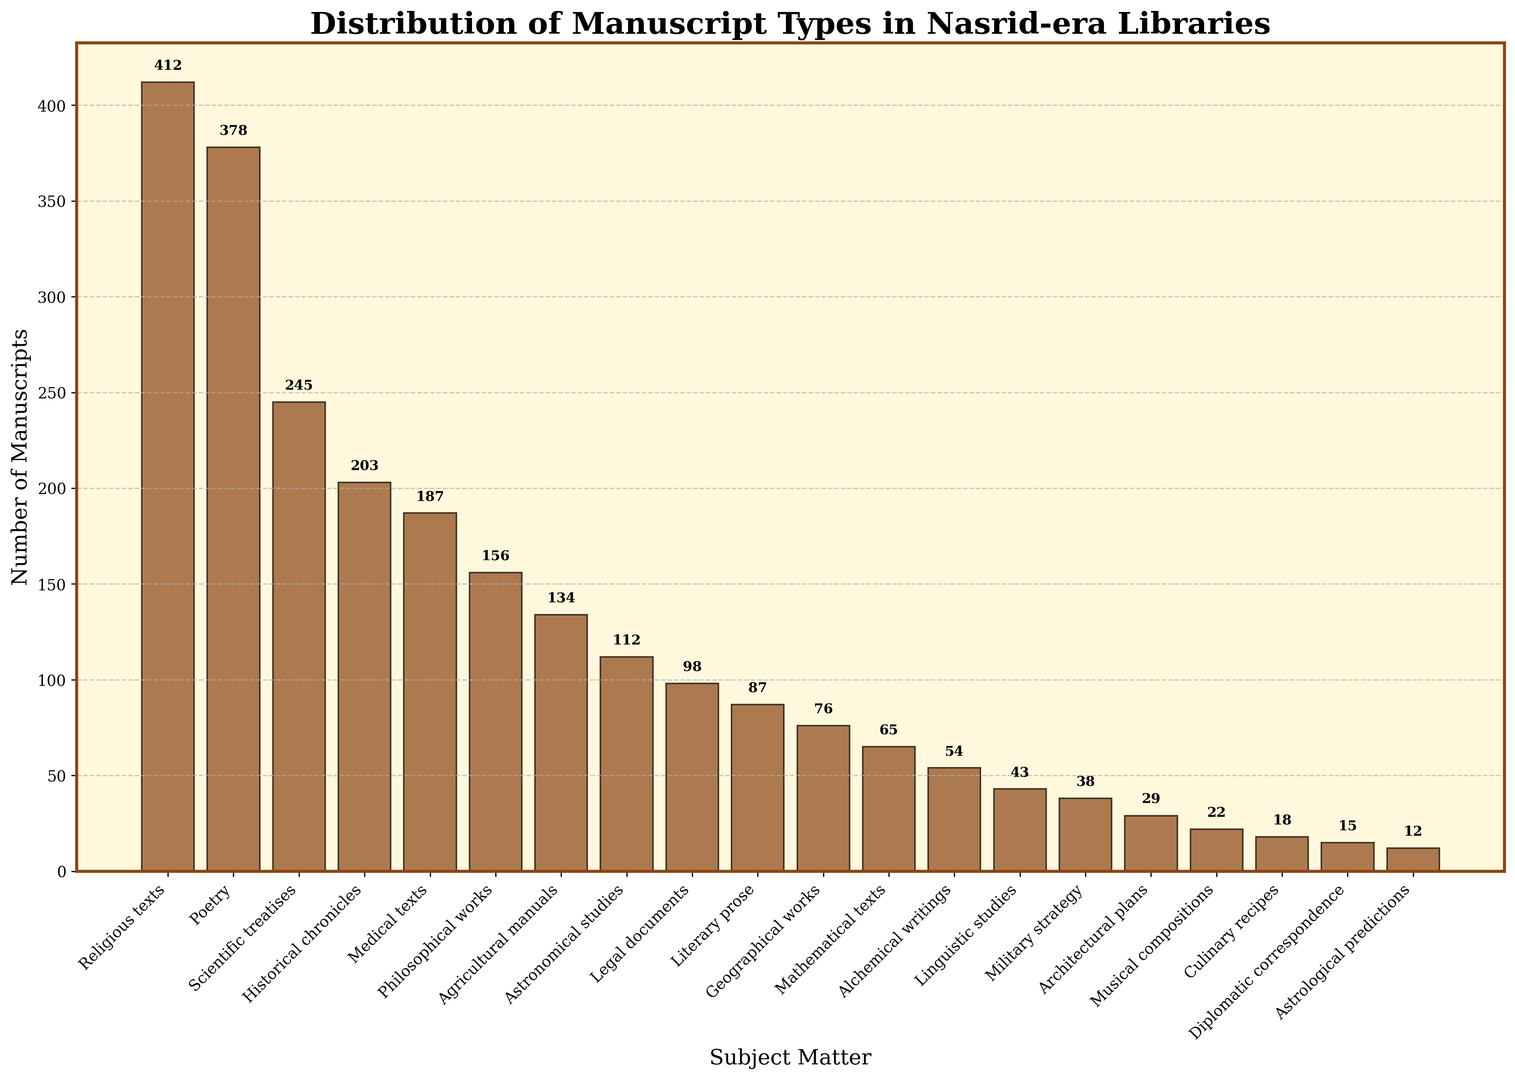Which subject matter has the highest number of manuscripts? By looking at the height of the bars, the highest bar corresponds to "Religious texts" which clearly exceeds the heights of the other bars.
Answer: Religious texts Which subject matter has the lowest number of manuscripts? Observing the bar heights, the shortest bar corresponds to "Astrological predictions," showing that it has the fewest manuscripts.
Answer: Astrological predictions How many more Religious texts are there than Astronomical studies? The bar for Religious texts is at 412 and the bar for Astronomical studies is at 112. Subtraction will give us the difference: 412 - 112 = 300.
Answer: 300 Which has more manuscripts: Poetry or Medical texts? Comparing the heights of the two bars, the bar for Poetry (378) is taller than the bar for Medical texts (187).
Answer: Poetry What is the total number of manuscripts for Agricultural manuals, Mathematical texts, and Culinary recipes combined? Add the values for these three categories: 134 (Agricultural manuals) + 65 (Mathematical texts) + 18 (Culinary recipes) = 217.
Answer: 217 Are there more manuscripts categorized under Historical chronicles or Scientific treatises? By comparing the bar heights, Scientific treatises (245) is taller than Historical chronicles (203).
Answer: Scientific treatises How many manuscripts are there in total for subjects that start with the letter "A"? Subjects that start with 'A' are Agricultural manuals (134), Astronomical studies (112), and Architectural plans (29). Adding these gives: 134 + 112 + 29 = 275.
Answer: 275 Which subject has more manuscripts: Philosophical works or Musical compositions? Comparing the bars, Philosophical works (156) is taller than Musical compositions (22).
Answer: Philosophical works What is the difference in the number of manuscripts between Legal documents and Geographical works? Looking at the bars for these subjects: Legal documents have 98 manuscripts, and Geographical works have 76 manuscripts. Subtracting these gives: 98 - 76 = 22.
Answer: 22 What is the sum of Religious texts, Poetry, and Scientific treatises manuscripts? Adding these values: 412 (Religious texts) + 378 (Poetry) + 245 (Scientific treatises) = 1035.
Answer: 1035 